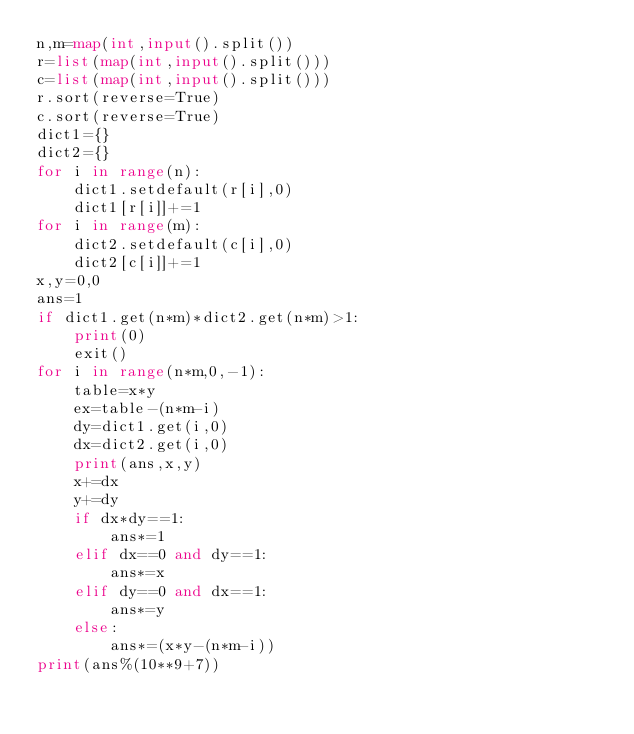<code> <loc_0><loc_0><loc_500><loc_500><_Python_>n,m=map(int,input().split())
r=list(map(int,input().split()))
c=list(map(int,input().split()))
r.sort(reverse=True)
c.sort(reverse=True)
dict1={}
dict2={}
for i in range(n):
    dict1.setdefault(r[i],0)
    dict1[r[i]]+=1
for i in range(m):
    dict2.setdefault(c[i],0)
    dict2[c[i]]+=1
x,y=0,0
ans=1
if dict1.get(n*m)*dict2.get(n*m)>1:
    print(0)
    exit()
for i in range(n*m,0,-1):
    table=x*y
    ex=table-(n*m-i)
    dy=dict1.get(i,0)
    dx=dict2.get(i,0)
    print(ans,x,y)
    x+=dx
    y+=dy
    if dx*dy==1:
        ans*=1
    elif dx==0 and dy==1:
        ans*=x
    elif dy==0 and dx==1:
        ans*=y
    else:
        ans*=(x*y-(n*m-i))
print(ans%(10**9+7))</code> 